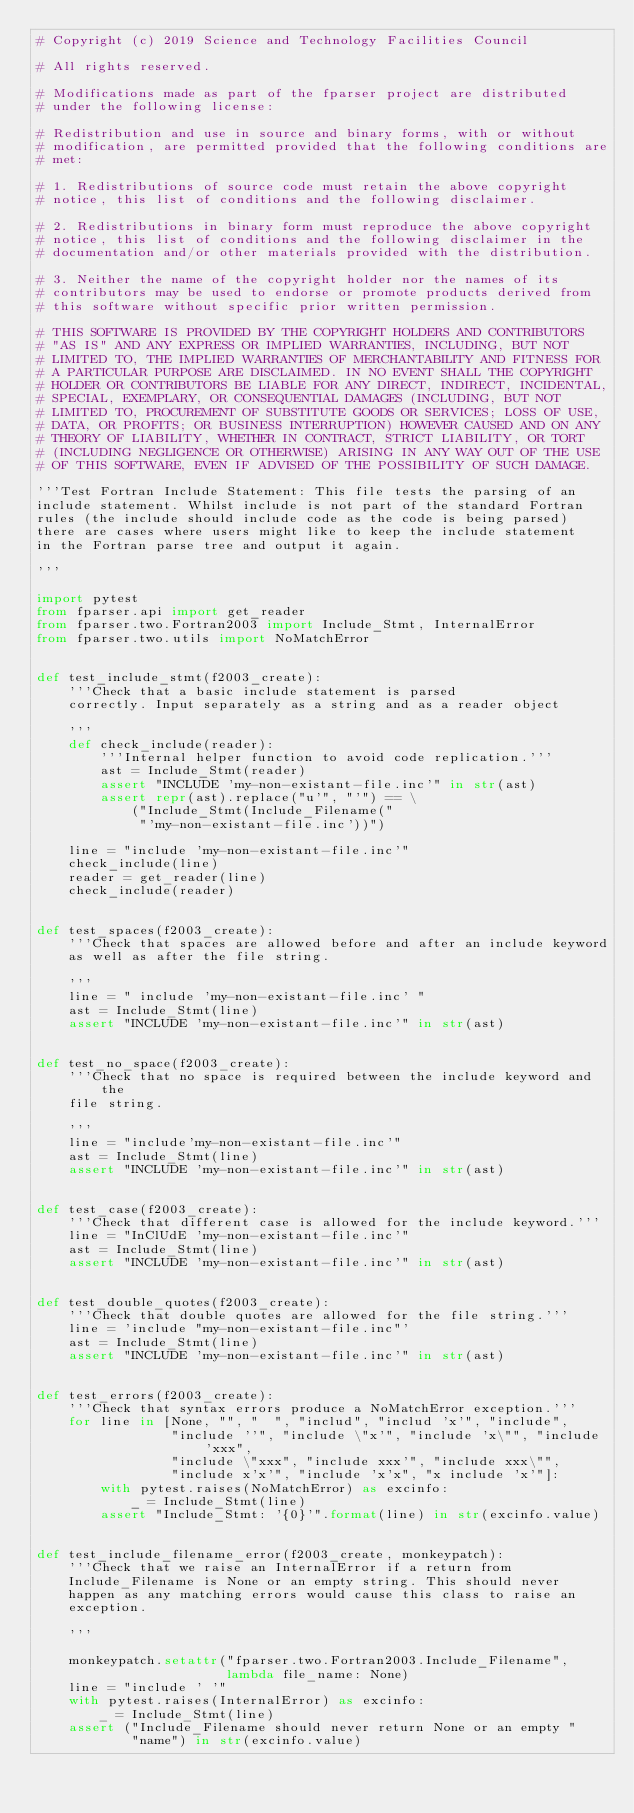Convert code to text. <code><loc_0><loc_0><loc_500><loc_500><_Python_># Copyright (c) 2019 Science and Technology Facilities Council

# All rights reserved.

# Modifications made as part of the fparser project are distributed
# under the following license:

# Redistribution and use in source and binary forms, with or without
# modification, are permitted provided that the following conditions are
# met:

# 1. Redistributions of source code must retain the above copyright
# notice, this list of conditions and the following disclaimer.

# 2. Redistributions in binary form must reproduce the above copyright
# notice, this list of conditions and the following disclaimer in the
# documentation and/or other materials provided with the distribution.

# 3. Neither the name of the copyright holder nor the names of its
# contributors may be used to endorse or promote products derived from
# this software without specific prior written permission.

# THIS SOFTWARE IS PROVIDED BY THE COPYRIGHT HOLDERS AND CONTRIBUTORS
# "AS IS" AND ANY EXPRESS OR IMPLIED WARRANTIES, INCLUDING, BUT NOT
# LIMITED TO, THE IMPLIED WARRANTIES OF MERCHANTABILITY AND FITNESS FOR
# A PARTICULAR PURPOSE ARE DISCLAIMED. IN NO EVENT SHALL THE COPYRIGHT
# HOLDER OR CONTRIBUTORS BE LIABLE FOR ANY DIRECT, INDIRECT, INCIDENTAL,
# SPECIAL, EXEMPLARY, OR CONSEQUENTIAL DAMAGES (INCLUDING, BUT NOT
# LIMITED TO, PROCUREMENT OF SUBSTITUTE GOODS OR SERVICES; LOSS OF USE,
# DATA, OR PROFITS; OR BUSINESS INTERRUPTION) HOWEVER CAUSED AND ON ANY
# THEORY OF LIABILITY, WHETHER IN CONTRACT, STRICT LIABILITY, OR TORT
# (INCLUDING NEGLIGENCE OR OTHERWISE) ARISING IN ANY WAY OUT OF THE USE
# OF THIS SOFTWARE, EVEN IF ADVISED OF THE POSSIBILITY OF SUCH DAMAGE.

'''Test Fortran Include Statement: This file tests the parsing of an
include statement. Whilst include is not part of the standard Fortran
rules (the include should include code as the code is being parsed)
there are cases where users might like to keep the include statement
in the Fortran parse tree and output it again.

'''

import pytest
from fparser.api import get_reader
from fparser.two.Fortran2003 import Include_Stmt, InternalError
from fparser.two.utils import NoMatchError


def test_include_stmt(f2003_create):
    '''Check that a basic include statement is parsed
    correctly. Input separately as a string and as a reader object

    '''
    def check_include(reader):
        '''Internal helper function to avoid code replication.'''
        ast = Include_Stmt(reader)
        assert "INCLUDE 'my-non-existant-file.inc'" in str(ast)
        assert repr(ast).replace("u'", "'") == \
            ("Include_Stmt(Include_Filename("
             "'my-non-existant-file.inc'))")

    line = "include 'my-non-existant-file.inc'"
    check_include(line)
    reader = get_reader(line)
    check_include(reader)


def test_spaces(f2003_create):
    '''Check that spaces are allowed before and after an include keyword
    as well as after the file string.

    '''
    line = " include 'my-non-existant-file.inc' "
    ast = Include_Stmt(line)
    assert "INCLUDE 'my-non-existant-file.inc'" in str(ast)


def test_no_space(f2003_create):
    '''Check that no space is required between the include keyword and the
    file string.

    '''
    line = "include'my-non-existant-file.inc'"
    ast = Include_Stmt(line)
    assert "INCLUDE 'my-non-existant-file.inc'" in str(ast)


def test_case(f2003_create):
    '''Check that different case is allowed for the include keyword.'''
    line = "InClUdE 'my-non-existant-file.inc'"
    ast = Include_Stmt(line)
    assert "INCLUDE 'my-non-existant-file.inc'" in str(ast)


def test_double_quotes(f2003_create):
    '''Check that double quotes are allowed for the file string.'''
    line = 'include "my-non-existant-file.inc"'
    ast = Include_Stmt(line)
    assert "INCLUDE 'my-non-existant-file.inc'" in str(ast)


def test_errors(f2003_create):
    '''Check that syntax errors produce a NoMatchError exception.'''
    for line in [None, "", "  ", "includ", "includ 'x'", "include",
                 "include ''", "include \"x'", "include 'x\"", "include 'xxx",
                 "include \"xxx", "include xxx'", "include xxx\"",
                 "include x'x'", "include 'x'x", "x include 'x'"]:
        with pytest.raises(NoMatchError) as excinfo:
            _ = Include_Stmt(line)
        assert "Include_Stmt: '{0}'".format(line) in str(excinfo.value)


def test_include_filename_error(f2003_create, monkeypatch):
    '''Check that we raise an InternalError if a return from
    Include_Filename is None or an empty string. This should never
    happen as any matching errors would cause this class to raise an
    exception.

    '''

    monkeypatch.setattr("fparser.two.Fortran2003.Include_Filename",
                        lambda file_name: None)
    line = "include ' '"
    with pytest.raises(InternalError) as excinfo:
        _ = Include_Stmt(line)
    assert ("Include_Filename should never return None or an empty "
            "name") in str(excinfo.value)
</code> 